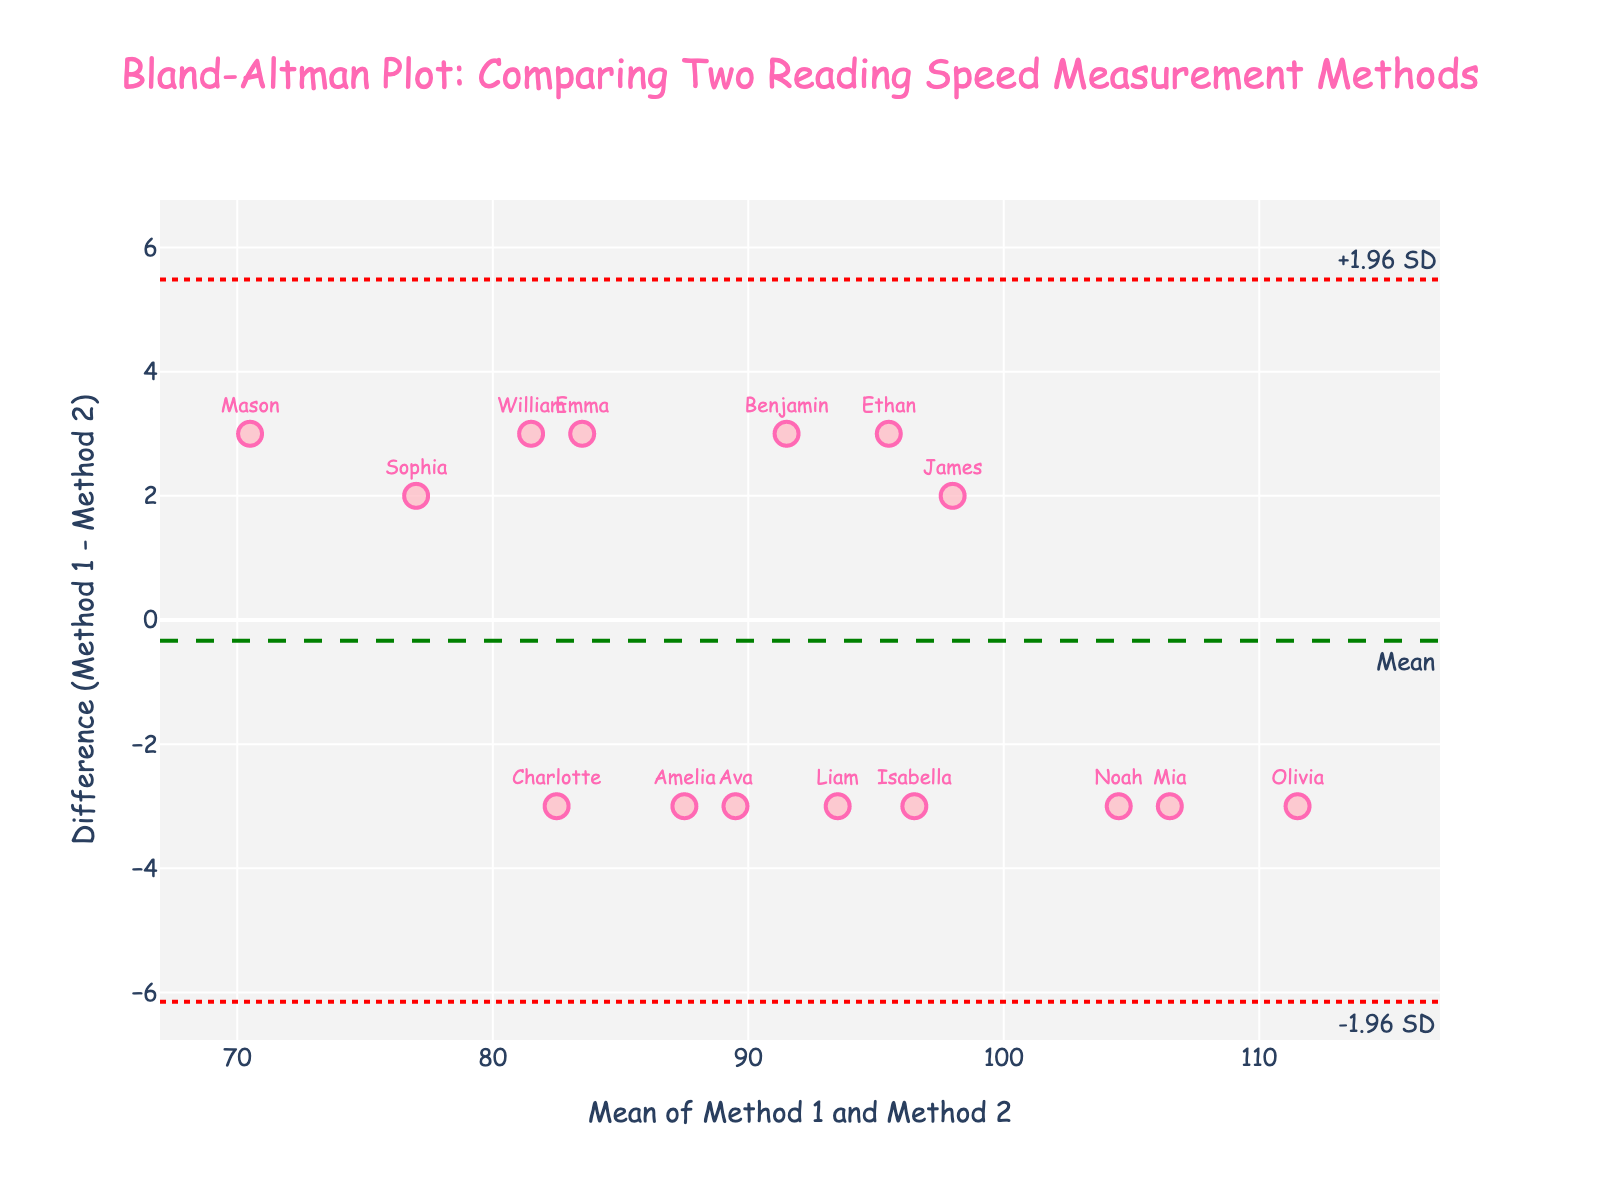What's the title of the plot? The title of the plot is usually displayed at the top of the figure.
Answer: Bland-Altman Plot: Comparing Two Reading Speed Measurement Methods How many children’s readings are displayed in the plot? Each point on the plot represents a child's reading speed measured by two methods. Count the number of points.
Answer: 15 What is the x-axis title? The x-axis title is typically found below the horizontal axis of the plot.
Answer: Mean of Method 1 and Method 2 What is the y-axis title? The y-axis title is typically found to the left of the vertical axis of the plot.
Answer: Difference (Method 1 - Method 2) Which child has the highest combined average reading speed? To find this, look for the data point with the highest position on the x-axis and check the label.
Answer: Olivia What is the mean difference between the two methods? The mean difference line is labeled on the plot, usually distinct with a different dashed or solid line style.
Answer: Green dashed line What are the upper and lower limits of agreement? These lines are generally labeled on the plot as +1.96 SD and -1.96 SD, respectively.
Answer: ±1.96 SD red dotted lines Which child has the maximum positive difference between the two methods? Look for the highest point on the y-axis and check the label.
Answer: Noah What is the range of values for the x-axis? This can be determined by reading the minimum and maximum values indicated on the x-axis.
Answer: [72, 113] Do most of the differences (Method 1 - Method 2) fall within the limits of agreement? Evaluate the position of most data points relative to the upper and lower limits of agreement lines.
Answer: Yes 